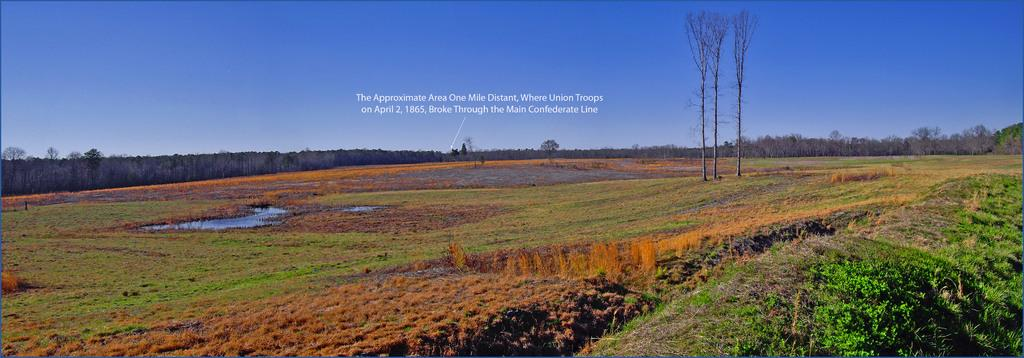What type of vegetation is present in the image? There is grass in the image. What else can be seen in the image besides grass? There is water visible in the image. What can be seen in the background of the image? There are trees and the sky visible in the background of the image. What type of knife is being used to rub the grass in the image? There is no knife or rubbing action present in the image; it features grass, water, trees, and the sky. 